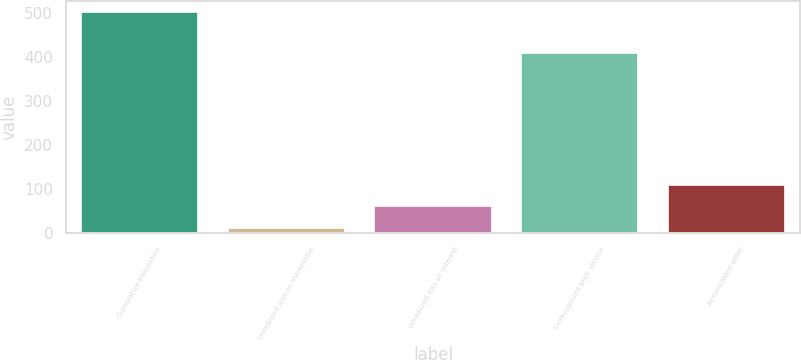<chart> <loc_0><loc_0><loc_500><loc_500><bar_chart><fcel>Cumulative translation<fcel>Unrealized loss on marketable<fcel>Unrealized loss on interest<fcel>Unrecognized prior service<fcel>Accumulated other<nl><fcel>501<fcel>12<fcel>60.9<fcel>409<fcel>109.8<nl></chart> 